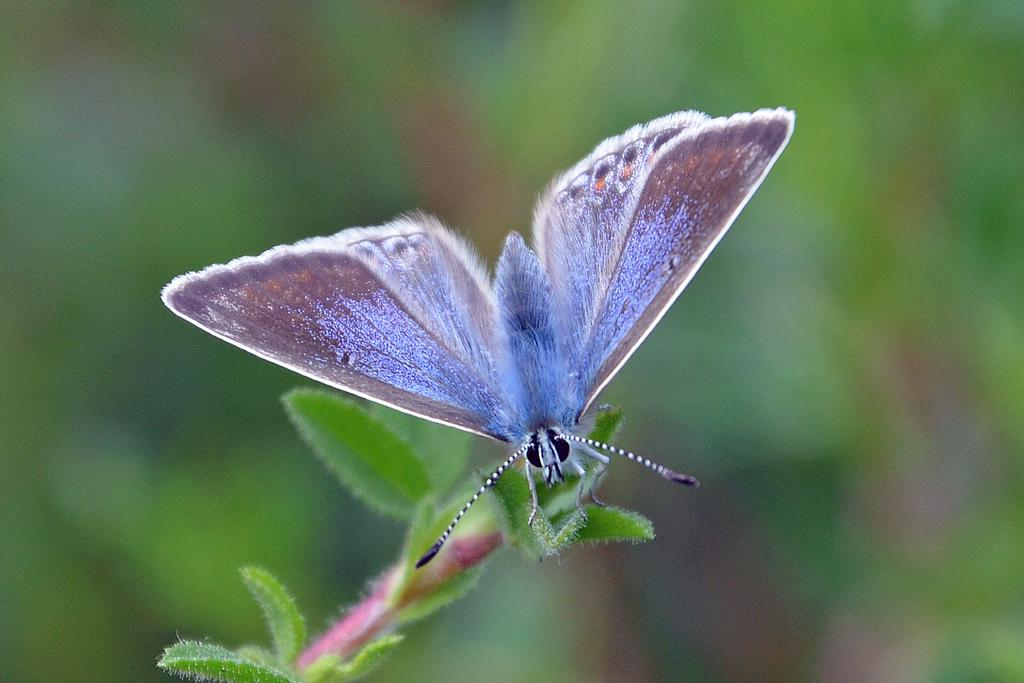What is the main subject of the image? There is a butterfly in the image. Where is the butterfly located? The butterfly is on a plant. Can you describe the background of the image? The background of the image is blurred. What type of footwear is the butterfly wearing in the image? Butterflies do not wear footwear, and there is no footwear present in the image. 